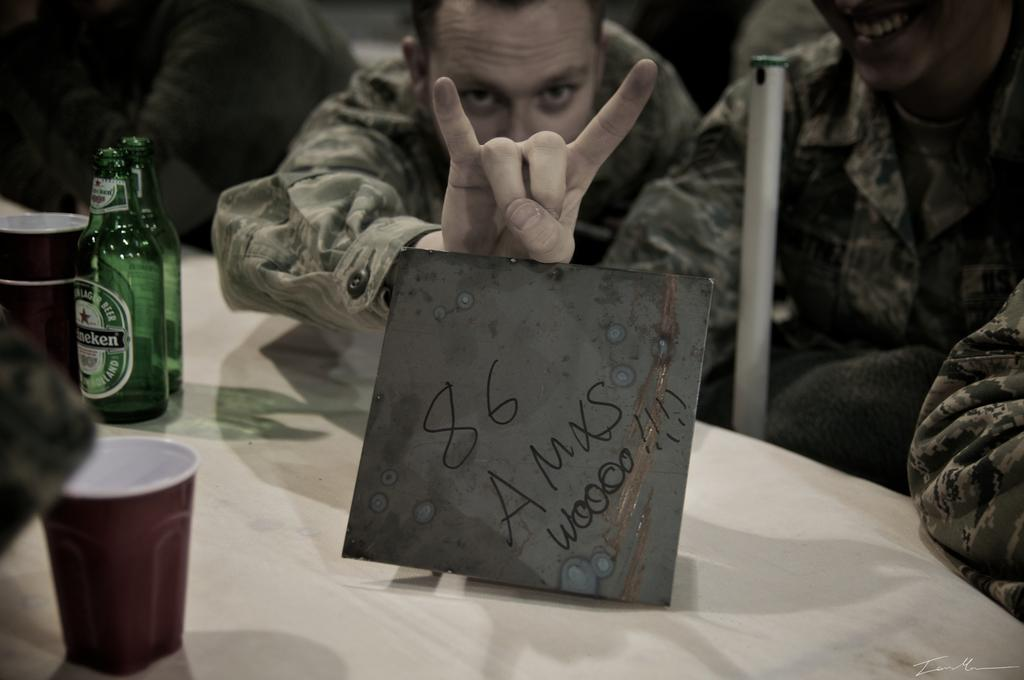How many men are seated in the image? There are two men seated on chairs in the image. What is the man holding in the image? There is a man holding a placard in the image. What objects can be seen on the table in the image? There are two bottles and two cups on the table in the image. What type of ice can be seen melting on the hook in the image? There is no ice or hook present in the image. 